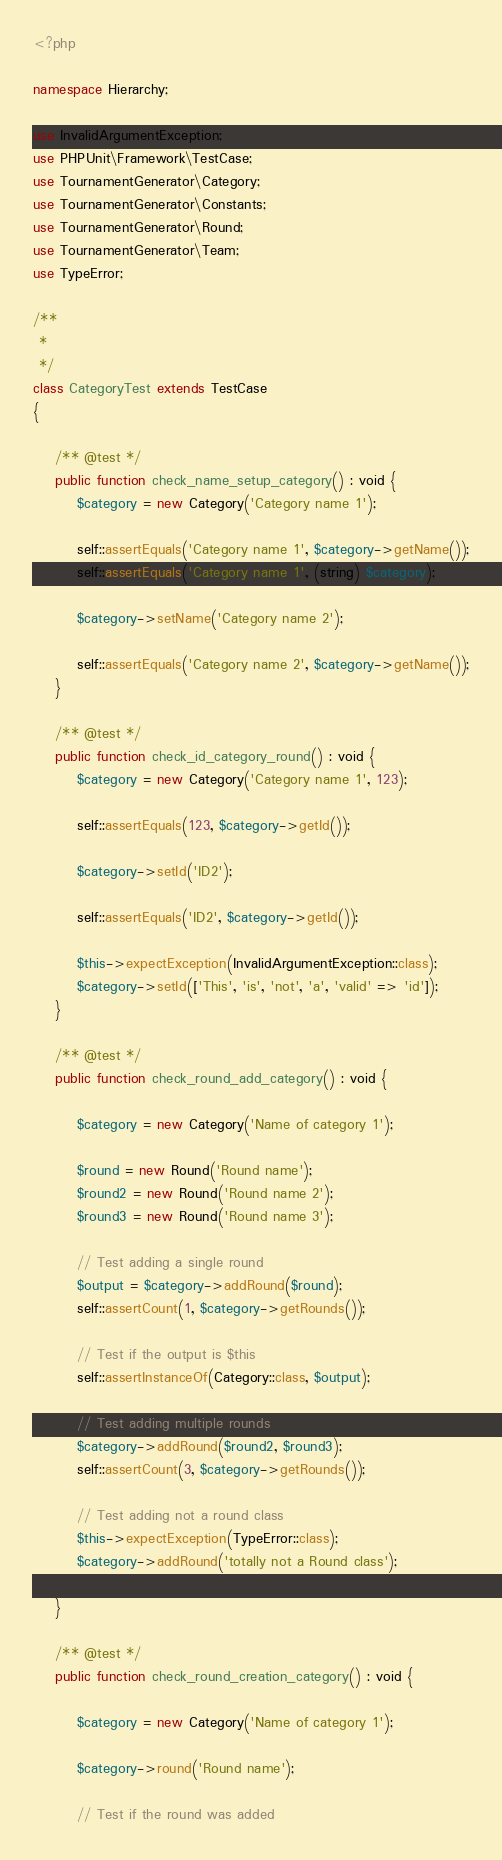<code> <loc_0><loc_0><loc_500><loc_500><_PHP_><?php

namespace Hierarchy;

use InvalidArgumentException;
use PHPUnit\Framework\TestCase;
use TournamentGenerator\Category;
use TournamentGenerator\Constants;
use TournamentGenerator\Round;
use TournamentGenerator\Team;
use TypeError;

/**
 *
 */
class CategoryTest extends TestCase
{

	/** @test */
	public function check_name_setup_category() : void {
		$category = new Category('Category name 1');

		self::assertEquals('Category name 1', $category->getName());
		self::assertEquals('Category name 1', (string) $category);

		$category->setName('Category name 2');

		self::assertEquals('Category name 2', $category->getName());
	}

	/** @test */
	public function check_id_category_round() : void {
		$category = new Category('Category name 1', 123);

		self::assertEquals(123, $category->getId());

		$category->setId('ID2');

		self::assertEquals('ID2', $category->getId());

		$this->expectException(InvalidArgumentException::class);
		$category->setId(['This', 'is', 'not', 'a', 'valid' => 'id']);
	}

	/** @test */
	public function check_round_add_category() : void {

		$category = new Category('Name of category 1');

		$round = new Round('Round name');
		$round2 = new Round('Round name 2');
		$round3 = new Round('Round name 3');

		// Test adding a single round
		$output = $category->addRound($round);
		self::assertCount(1, $category->getRounds());

		// Test if the output is $this
		self::assertInstanceOf(Category::class, $output);

		// Test adding multiple rounds
		$category->addRound($round2, $round3);
		self::assertCount(3, $category->getRounds());

		// Test adding not a round class
		$this->expectException(TypeError::class);
		$category->addRound('totally not a Round class');

	}

	/** @test */
	public function check_round_creation_category() : void {

		$category = new Category('Name of category 1');

		$category->round('Round name');

		// Test if the round was added</code> 